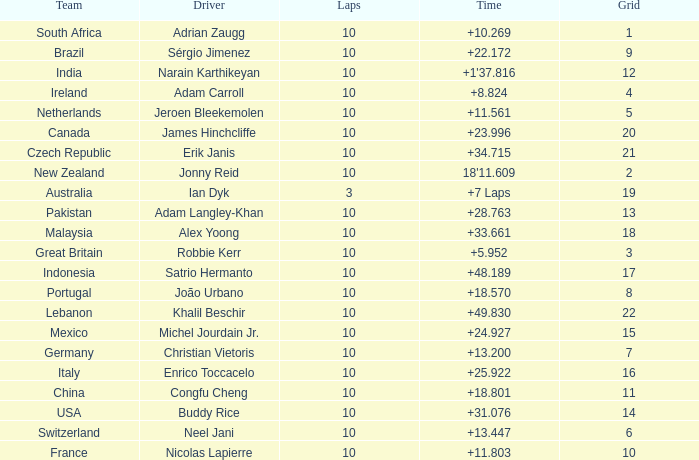What team had 10 Labs and the Driver was Alex Yoong? Malaysia. 